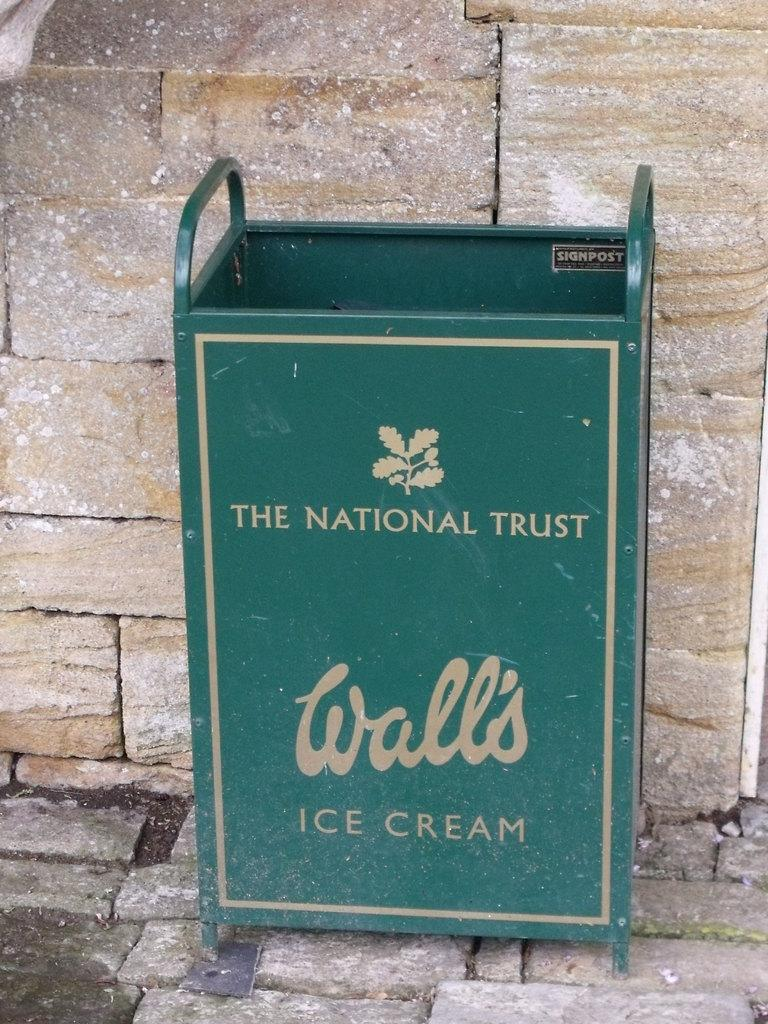Provide a one-sentence caption for the provided image. The green container has 'The National Trust' and 'Wall's Ice Cream' printed on it. 